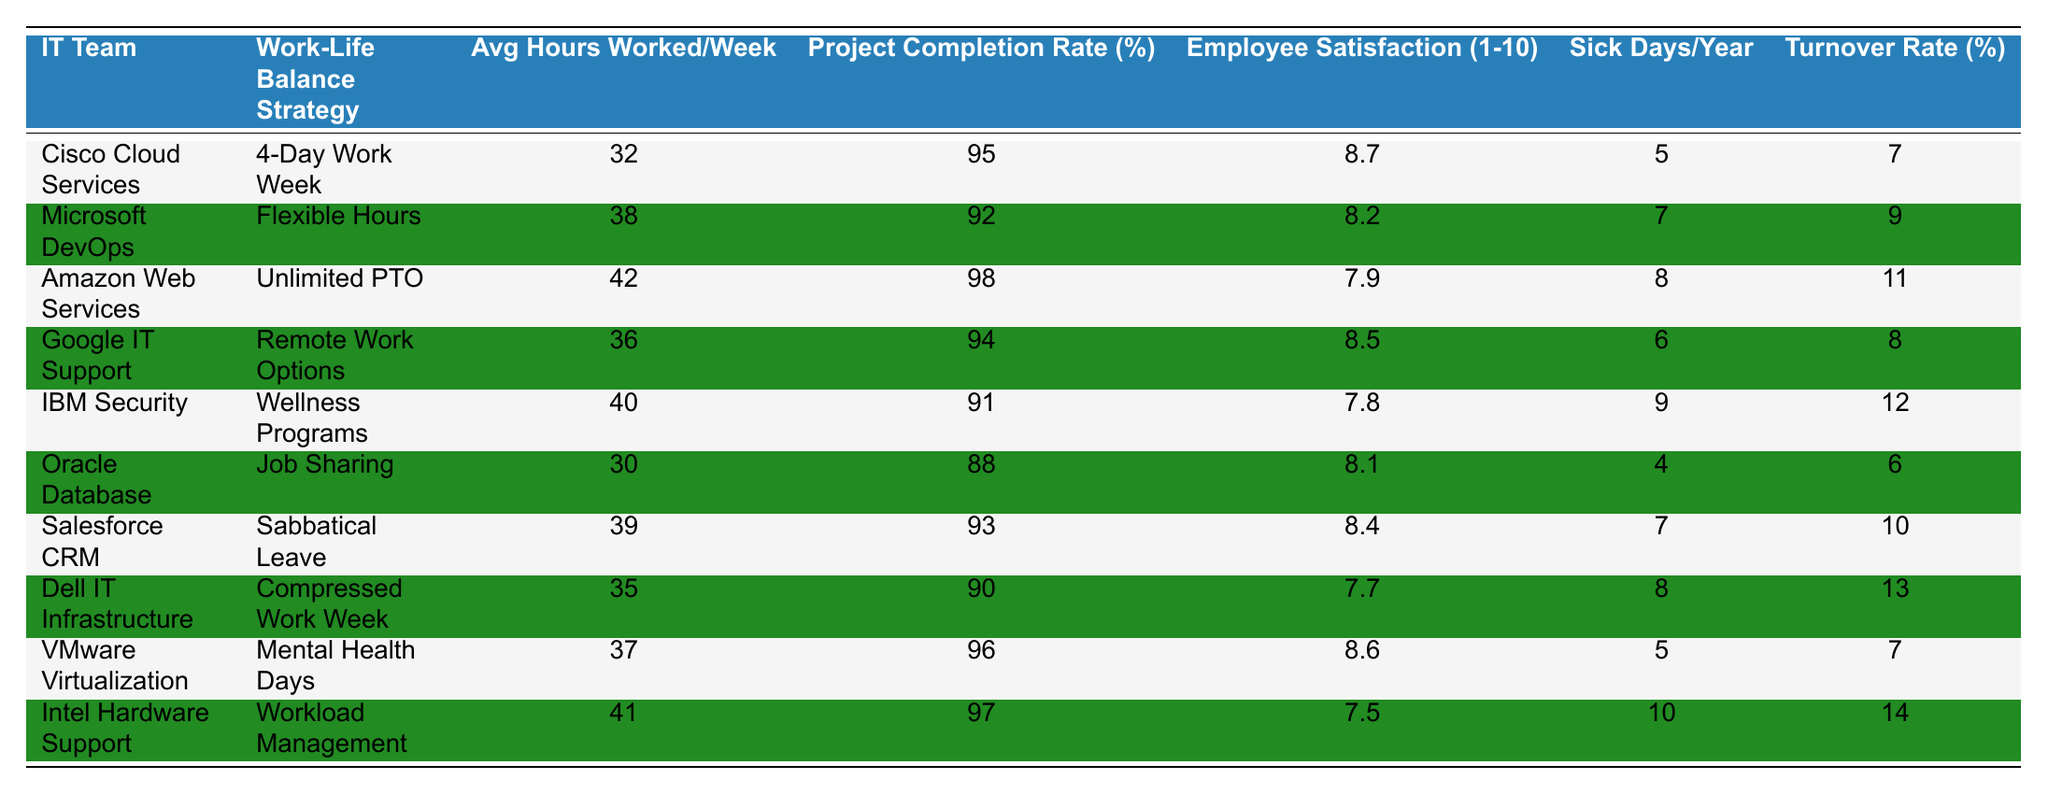What is the lowest project completion rate among the IT teams? The table shows project completion rates for all IT teams. The lowest value is 88%, which belongs to Oracle Database.
Answer: 88% Which IT team has the highest employee satisfaction score? By comparing the scores listed, Cisco Cloud Services has the highest employee satisfaction score of 8.7.
Answer: 8.7 How many sick days did employees at IBM Security take on average? The average number of sick days taken by IBM Security employees is directly listed in the table as 9.
Answer: 9 Which work-life balance strategy correlates with the lowest turnover rate? After analyzing the turnover rates for each strategy, we find that Oracle Database has the lowest turnover rate at 6%.
Answer: 6% What is the average number of sick days taken by all the IT teams? To find the average, we add up all the sick days (5 + 7 + 8 + 6 + 9 + 4 + 7 + 8 + 5 + 10 = 69) and divide by the number of teams (10). The average sick days taken are 69 / 10 = 6.9.
Answer: 6.9 Do all teams that offer unlimited PTO have high employee satisfaction scores? Checking the employee satisfaction scores for Amazon Web Services, which offers unlimited PTO, we see a score of 7.9. This is not considered high compared to others. So not all teams with unlimited PTO have high scores.
Answer: No Which work-life balance strategy has the highest average hours worked per week? The strategy with the highest hours worked is "Unlimited PTO" by Amazon Web Services, with an average of 42 hours worked per week.
Answer: 42 Compare the project completion rates of teams with flexible hours and 4-day work weeks. Microsoft DevOps with flexible hours has a completion rate of 92%, while Cisco Cloud Services with a 4-day work week has a rate of 95%. 95% is higher than 92%.
Answer: 95% is higher What is the total employee satisfaction score for all the IT teams combined? To find the total, we sum the satisfaction scores listed: (8.7 + 8.2 + 7.9 + 8.5 + 7.8 + 8.1 + 8.4 + 7.7 + 8.6 + 7.5 = 86.5). So, the total score is 86.5.
Answer: 86.5 Which IT team has the most sick days taken on average, and how many days were taken? From the table, Intel Hardware Support has the most sick days taken, which amounts to 10 days on average.
Answer: 10 